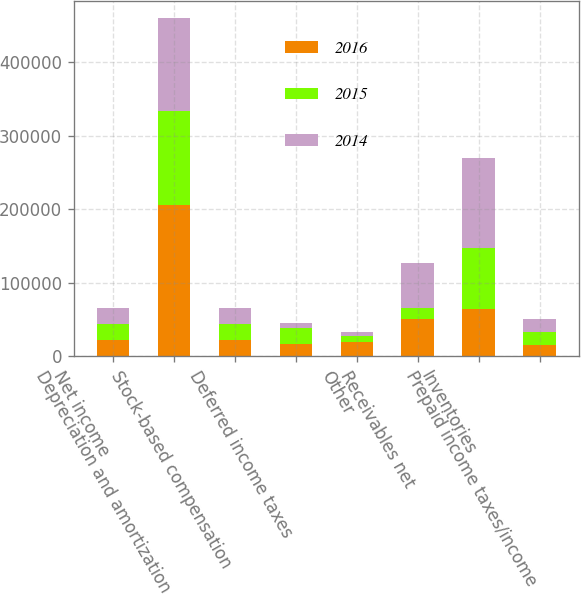Convert chart to OTSL. <chart><loc_0><loc_0><loc_500><loc_500><stacked_bar_chart><ecel><fcel>Net income<fcel>Depreciation and amortization<fcel>Stock-based compensation<fcel>Deferred income taxes<fcel>Other<fcel>Receivables net<fcel>Inventories<fcel>Prepaid income taxes/income<nl><fcel>2016<fcel>22021<fcel>206086<fcel>22472<fcel>16162<fcel>19550<fcel>50801<fcel>64114<fcel>14944<nl><fcel>2015<fcel>22021<fcel>128192<fcel>21336<fcel>22388<fcel>7348<fcel>14704<fcel>83188<fcel>17474<nl><fcel>2014<fcel>22021<fcel>125437<fcel>22021<fcel>6242<fcel>6269<fcel>61739<fcel>122590<fcel>18428<nl></chart> 